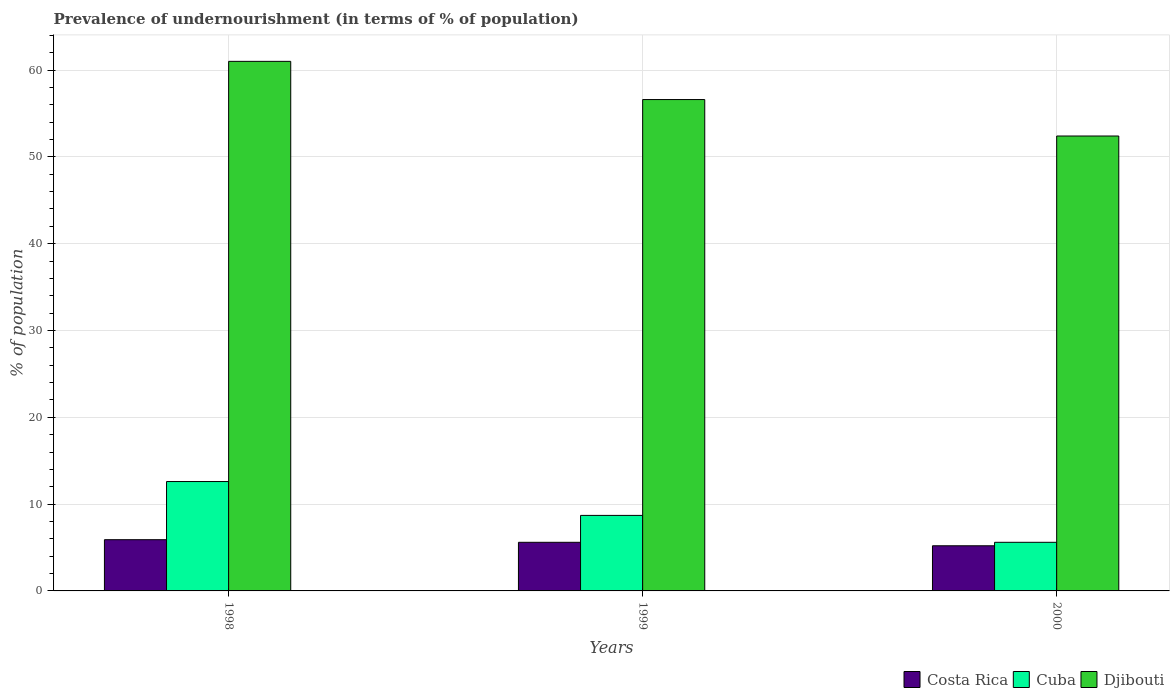How many different coloured bars are there?
Give a very brief answer. 3. How many groups of bars are there?
Provide a succinct answer. 3. How many bars are there on the 1st tick from the left?
Your response must be concise. 3. Across all years, what is the minimum percentage of undernourished population in Djibouti?
Your answer should be compact. 52.4. What is the total percentage of undernourished population in Djibouti in the graph?
Keep it short and to the point. 170. What is the difference between the percentage of undernourished population in Djibouti in 1999 and that in 2000?
Provide a succinct answer. 4.2. What is the difference between the percentage of undernourished population in Costa Rica in 2000 and the percentage of undernourished population in Cuba in 1998?
Provide a succinct answer. -7.4. What is the average percentage of undernourished population in Costa Rica per year?
Your answer should be very brief. 5.57. In the year 1998, what is the difference between the percentage of undernourished population in Djibouti and percentage of undernourished population in Costa Rica?
Your answer should be very brief. 55.1. In how many years, is the percentage of undernourished population in Cuba greater than 8 %?
Make the answer very short. 2. What is the ratio of the percentage of undernourished population in Costa Rica in 1998 to that in 2000?
Offer a terse response. 1.13. What is the difference between the highest and the second highest percentage of undernourished population in Cuba?
Offer a very short reply. 3.9. What is the difference between the highest and the lowest percentage of undernourished population in Cuba?
Ensure brevity in your answer.  7. In how many years, is the percentage of undernourished population in Costa Rica greater than the average percentage of undernourished population in Costa Rica taken over all years?
Provide a succinct answer. 2. Is the sum of the percentage of undernourished population in Cuba in 1998 and 2000 greater than the maximum percentage of undernourished population in Djibouti across all years?
Ensure brevity in your answer.  No. What does the 2nd bar from the left in 1999 represents?
Provide a succinct answer. Cuba. What does the 1st bar from the right in 1999 represents?
Provide a succinct answer. Djibouti. Is it the case that in every year, the sum of the percentage of undernourished population in Djibouti and percentage of undernourished population in Cuba is greater than the percentage of undernourished population in Costa Rica?
Your answer should be compact. Yes. How many years are there in the graph?
Give a very brief answer. 3. What is the difference between two consecutive major ticks on the Y-axis?
Give a very brief answer. 10. Are the values on the major ticks of Y-axis written in scientific E-notation?
Ensure brevity in your answer.  No. Does the graph contain grids?
Your response must be concise. Yes. Where does the legend appear in the graph?
Give a very brief answer. Bottom right. How are the legend labels stacked?
Your answer should be very brief. Horizontal. What is the title of the graph?
Give a very brief answer. Prevalence of undernourishment (in terms of % of population). What is the label or title of the Y-axis?
Keep it short and to the point. % of population. What is the % of population in Costa Rica in 1998?
Offer a terse response. 5.9. What is the % of population in Djibouti in 1998?
Provide a short and direct response. 61. What is the % of population of Djibouti in 1999?
Your answer should be compact. 56.6. What is the % of population of Cuba in 2000?
Give a very brief answer. 5.6. What is the % of population of Djibouti in 2000?
Make the answer very short. 52.4. Across all years, what is the maximum % of population of Costa Rica?
Provide a succinct answer. 5.9. Across all years, what is the maximum % of population in Cuba?
Keep it short and to the point. 12.6. Across all years, what is the maximum % of population of Djibouti?
Offer a very short reply. 61. Across all years, what is the minimum % of population of Cuba?
Offer a terse response. 5.6. Across all years, what is the minimum % of population of Djibouti?
Provide a short and direct response. 52.4. What is the total % of population in Costa Rica in the graph?
Your response must be concise. 16.7. What is the total % of population of Cuba in the graph?
Your answer should be compact. 26.9. What is the total % of population in Djibouti in the graph?
Give a very brief answer. 170. What is the difference between the % of population in Djibouti in 1998 and that in 1999?
Provide a short and direct response. 4.4. What is the difference between the % of population in Djibouti in 1998 and that in 2000?
Ensure brevity in your answer.  8.6. What is the difference between the % of population of Costa Rica in 1999 and that in 2000?
Offer a terse response. 0.4. What is the difference between the % of population of Cuba in 1999 and that in 2000?
Provide a succinct answer. 3.1. What is the difference between the % of population of Costa Rica in 1998 and the % of population of Djibouti in 1999?
Your response must be concise. -50.7. What is the difference between the % of population of Cuba in 1998 and the % of population of Djibouti in 1999?
Make the answer very short. -44. What is the difference between the % of population in Costa Rica in 1998 and the % of population in Cuba in 2000?
Provide a succinct answer. 0.3. What is the difference between the % of population in Costa Rica in 1998 and the % of population in Djibouti in 2000?
Your answer should be very brief. -46.5. What is the difference between the % of population of Cuba in 1998 and the % of population of Djibouti in 2000?
Ensure brevity in your answer.  -39.8. What is the difference between the % of population of Costa Rica in 1999 and the % of population of Djibouti in 2000?
Offer a very short reply. -46.8. What is the difference between the % of population in Cuba in 1999 and the % of population in Djibouti in 2000?
Your response must be concise. -43.7. What is the average % of population of Costa Rica per year?
Give a very brief answer. 5.57. What is the average % of population of Cuba per year?
Ensure brevity in your answer.  8.97. What is the average % of population of Djibouti per year?
Offer a terse response. 56.67. In the year 1998, what is the difference between the % of population of Costa Rica and % of population of Cuba?
Your answer should be compact. -6.7. In the year 1998, what is the difference between the % of population of Costa Rica and % of population of Djibouti?
Make the answer very short. -55.1. In the year 1998, what is the difference between the % of population of Cuba and % of population of Djibouti?
Keep it short and to the point. -48.4. In the year 1999, what is the difference between the % of population of Costa Rica and % of population of Cuba?
Offer a terse response. -3.1. In the year 1999, what is the difference between the % of population of Costa Rica and % of population of Djibouti?
Make the answer very short. -51. In the year 1999, what is the difference between the % of population of Cuba and % of population of Djibouti?
Give a very brief answer. -47.9. In the year 2000, what is the difference between the % of population in Costa Rica and % of population in Djibouti?
Give a very brief answer. -47.2. In the year 2000, what is the difference between the % of population in Cuba and % of population in Djibouti?
Give a very brief answer. -46.8. What is the ratio of the % of population of Costa Rica in 1998 to that in 1999?
Keep it short and to the point. 1.05. What is the ratio of the % of population of Cuba in 1998 to that in 1999?
Your answer should be compact. 1.45. What is the ratio of the % of population in Djibouti in 1998 to that in 1999?
Offer a terse response. 1.08. What is the ratio of the % of population in Costa Rica in 1998 to that in 2000?
Offer a very short reply. 1.13. What is the ratio of the % of population in Cuba in 1998 to that in 2000?
Your response must be concise. 2.25. What is the ratio of the % of population of Djibouti in 1998 to that in 2000?
Keep it short and to the point. 1.16. What is the ratio of the % of population of Costa Rica in 1999 to that in 2000?
Provide a short and direct response. 1.08. What is the ratio of the % of population in Cuba in 1999 to that in 2000?
Provide a succinct answer. 1.55. What is the ratio of the % of population of Djibouti in 1999 to that in 2000?
Provide a short and direct response. 1.08. What is the difference between the highest and the second highest % of population in Djibouti?
Ensure brevity in your answer.  4.4. What is the difference between the highest and the lowest % of population of Costa Rica?
Your answer should be very brief. 0.7. 